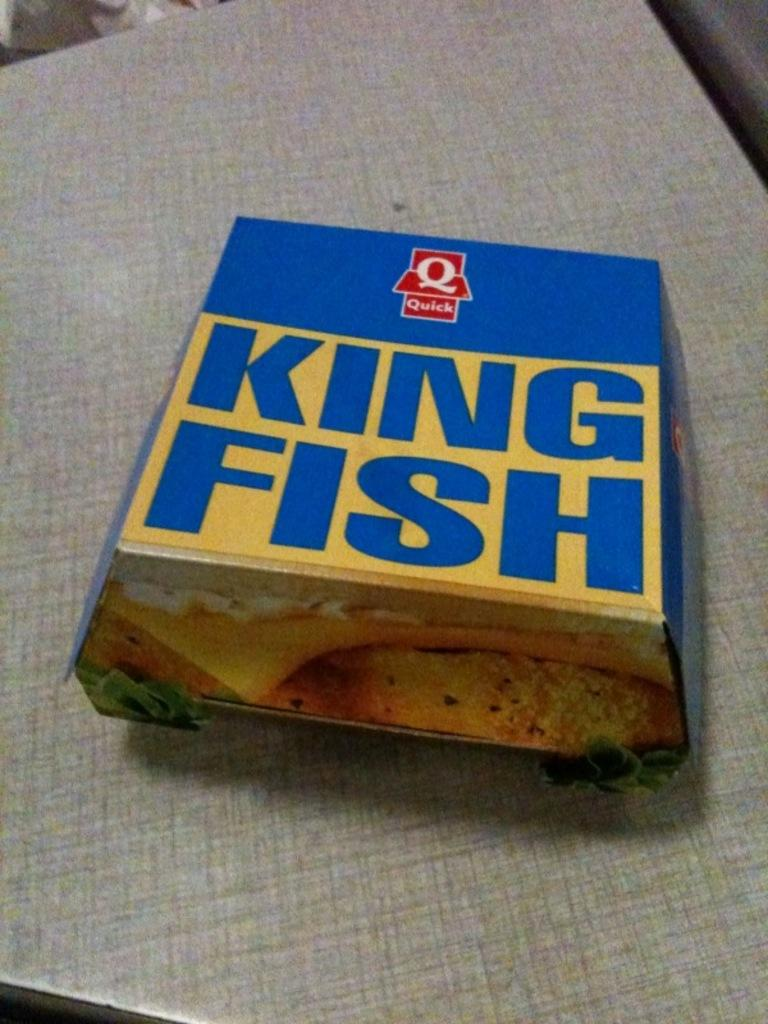What object is present in the image that is made of cardboard? There is a cardboard box in the image. Can you describe any text or images on the cardboard box? The cardboard box has a name on it and a picture on it. What is the cardboard box placed on in the image? The cardboard box is placed on a wooden board. What type of shoe is the girl wearing in the image? There is no girl or shoe present in the image; it only features a cardboard box placed on a wooden board. 